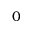<formula> <loc_0><loc_0><loc_500><loc_500>0</formula> 